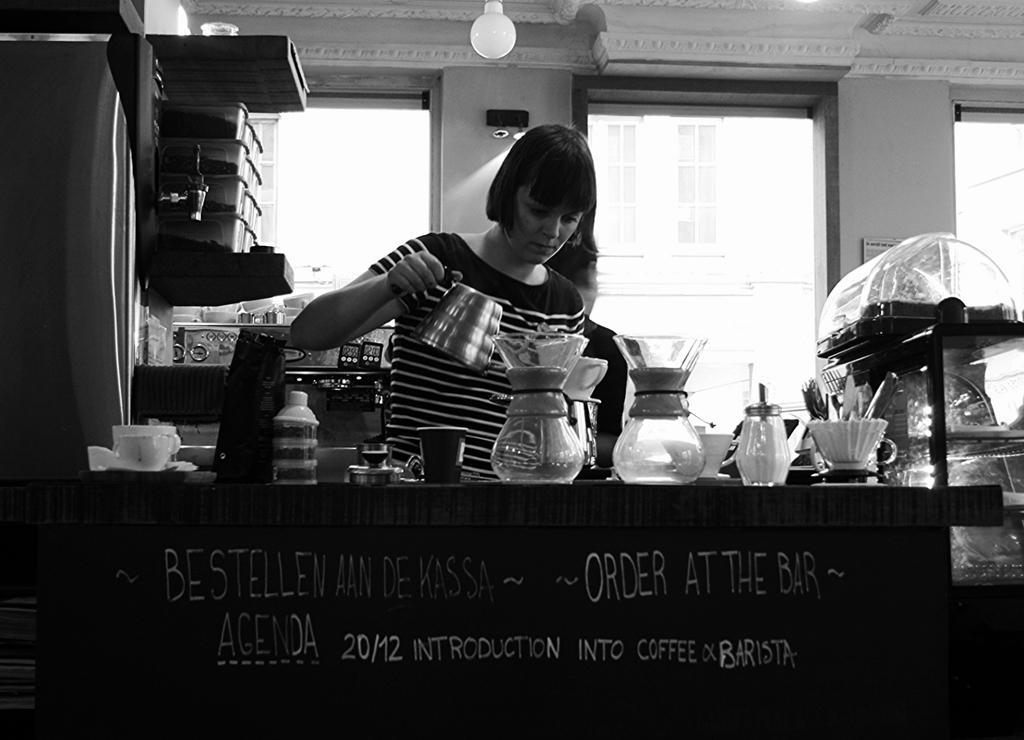How would you summarize this image in a sentence or two? In this image we can see two persons, one of them is holding an object, in front of her there is a table, on that there are some jugs, cups, jars, and some other objects, we can also see some text written on the table. We can see some boxes on the racks, there are some lights, walls, and windows, also we can see some boxes on the racks. 